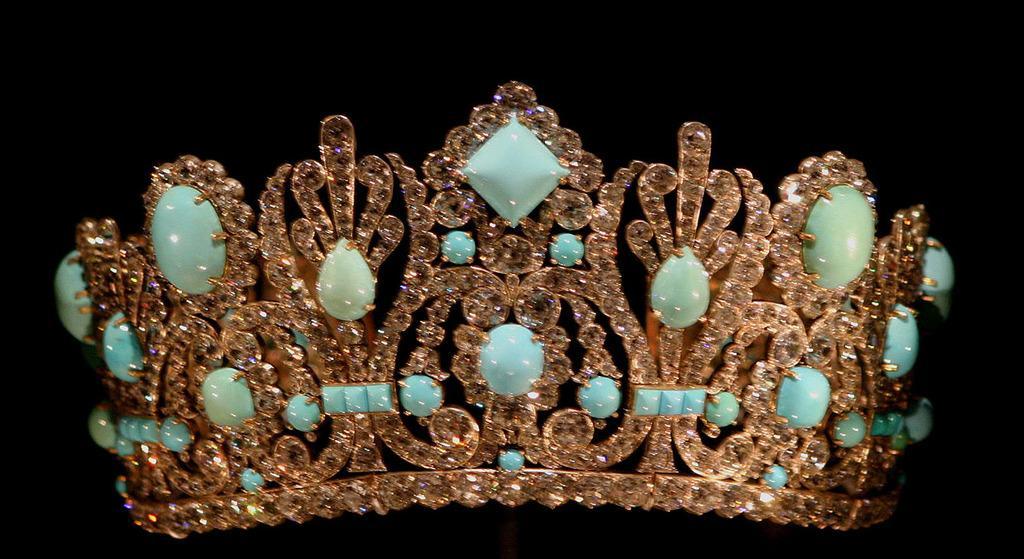Can you describe this image briefly? In this picture there is a crown, made of stones. The background is dark. 